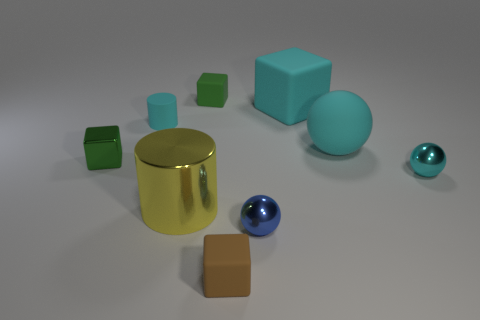Subtract 1 blocks. How many blocks are left? 3 Add 1 large cubes. How many objects exist? 10 Subtract all purple cubes. Subtract all red cylinders. How many cubes are left? 4 Subtract all blocks. How many objects are left? 5 Subtract all purple metal objects. Subtract all yellow metal cylinders. How many objects are left? 8 Add 2 rubber cylinders. How many rubber cylinders are left? 3 Add 1 small rubber objects. How many small rubber objects exist? 4 Subtract 0 red balls. How many objects are left? 9 